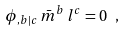<formula> <loc_0><loc_0><loc_500><loc_500>\phi _ { , b | c } \, \bar { m } ^ { b } \, l ^ { c } = 0 \ ,</formula> 